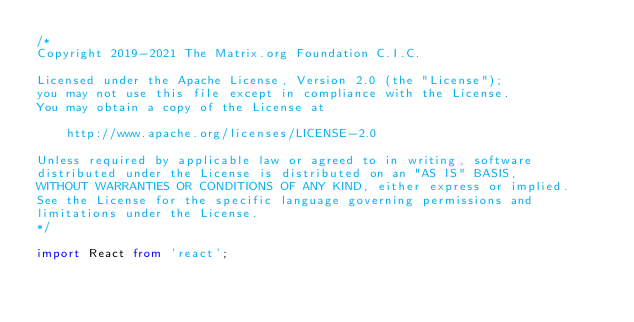<code> <loc_0><loc_0><loc_500><loc_500><_TypeScript_>/*
Copyright 2019-2021 The Matrix.org Foundation C.I.C.

Licensed under the Apache License, Version 2.0 (the "License");
you may not use this file except in compliance with the License.
You may obtain a copy of the License at

    http://www.apache.org/licenses/LICENSE-2.0

Unless required by applicable law or agreed to in writing, software
distributed under the License is distributed on an "AS IS" BASIS,
WITHOUT WARRANTIES OR CONDITIONS OF ANY KIND, either express or implied.
See the License for the specific language governing permissions and
limitations under the License.
*/

import React from 'react';</code> 